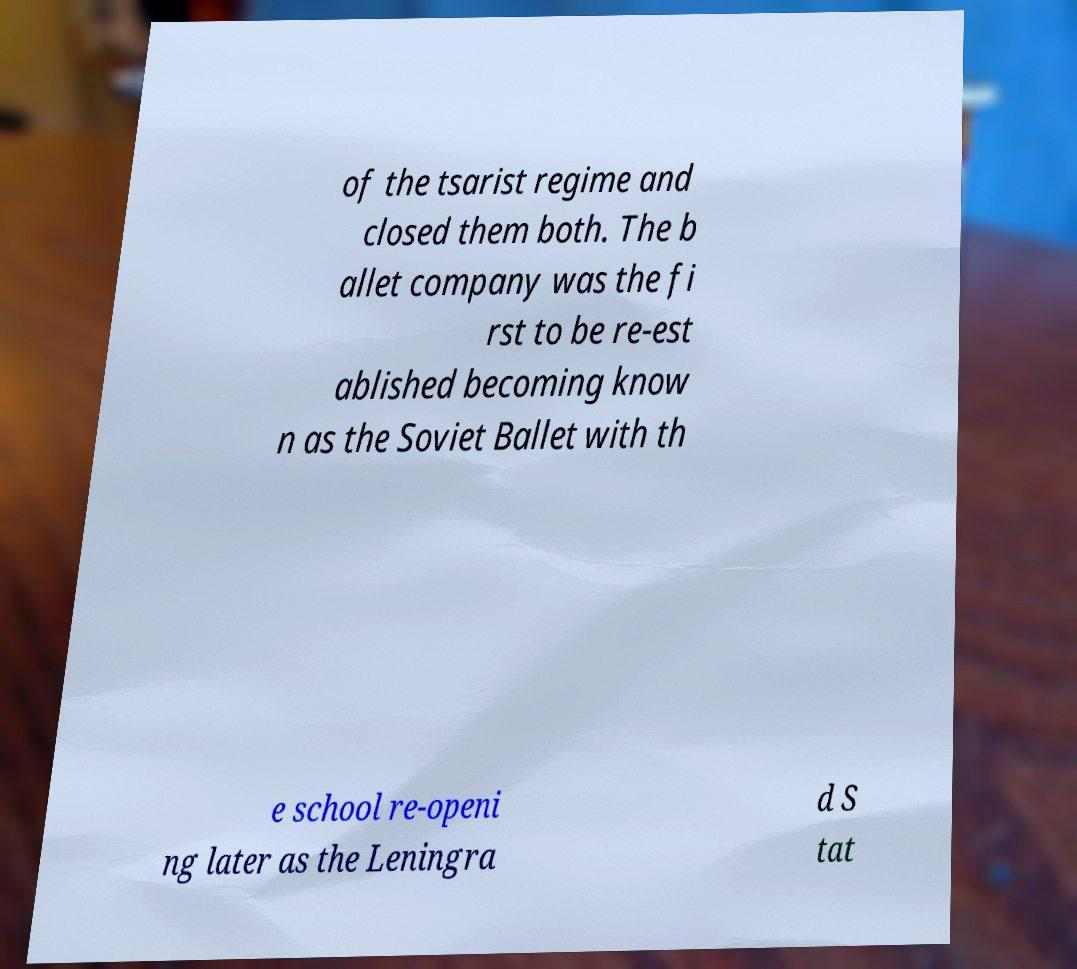Could you extract and type out the text from this image? of the tsarist regime and closed them both. The b allet company was the fi rst to be re-est ablished becoming know n as the Soviet Ballet with th e school re-openi ng later as the Leningra d S tat 